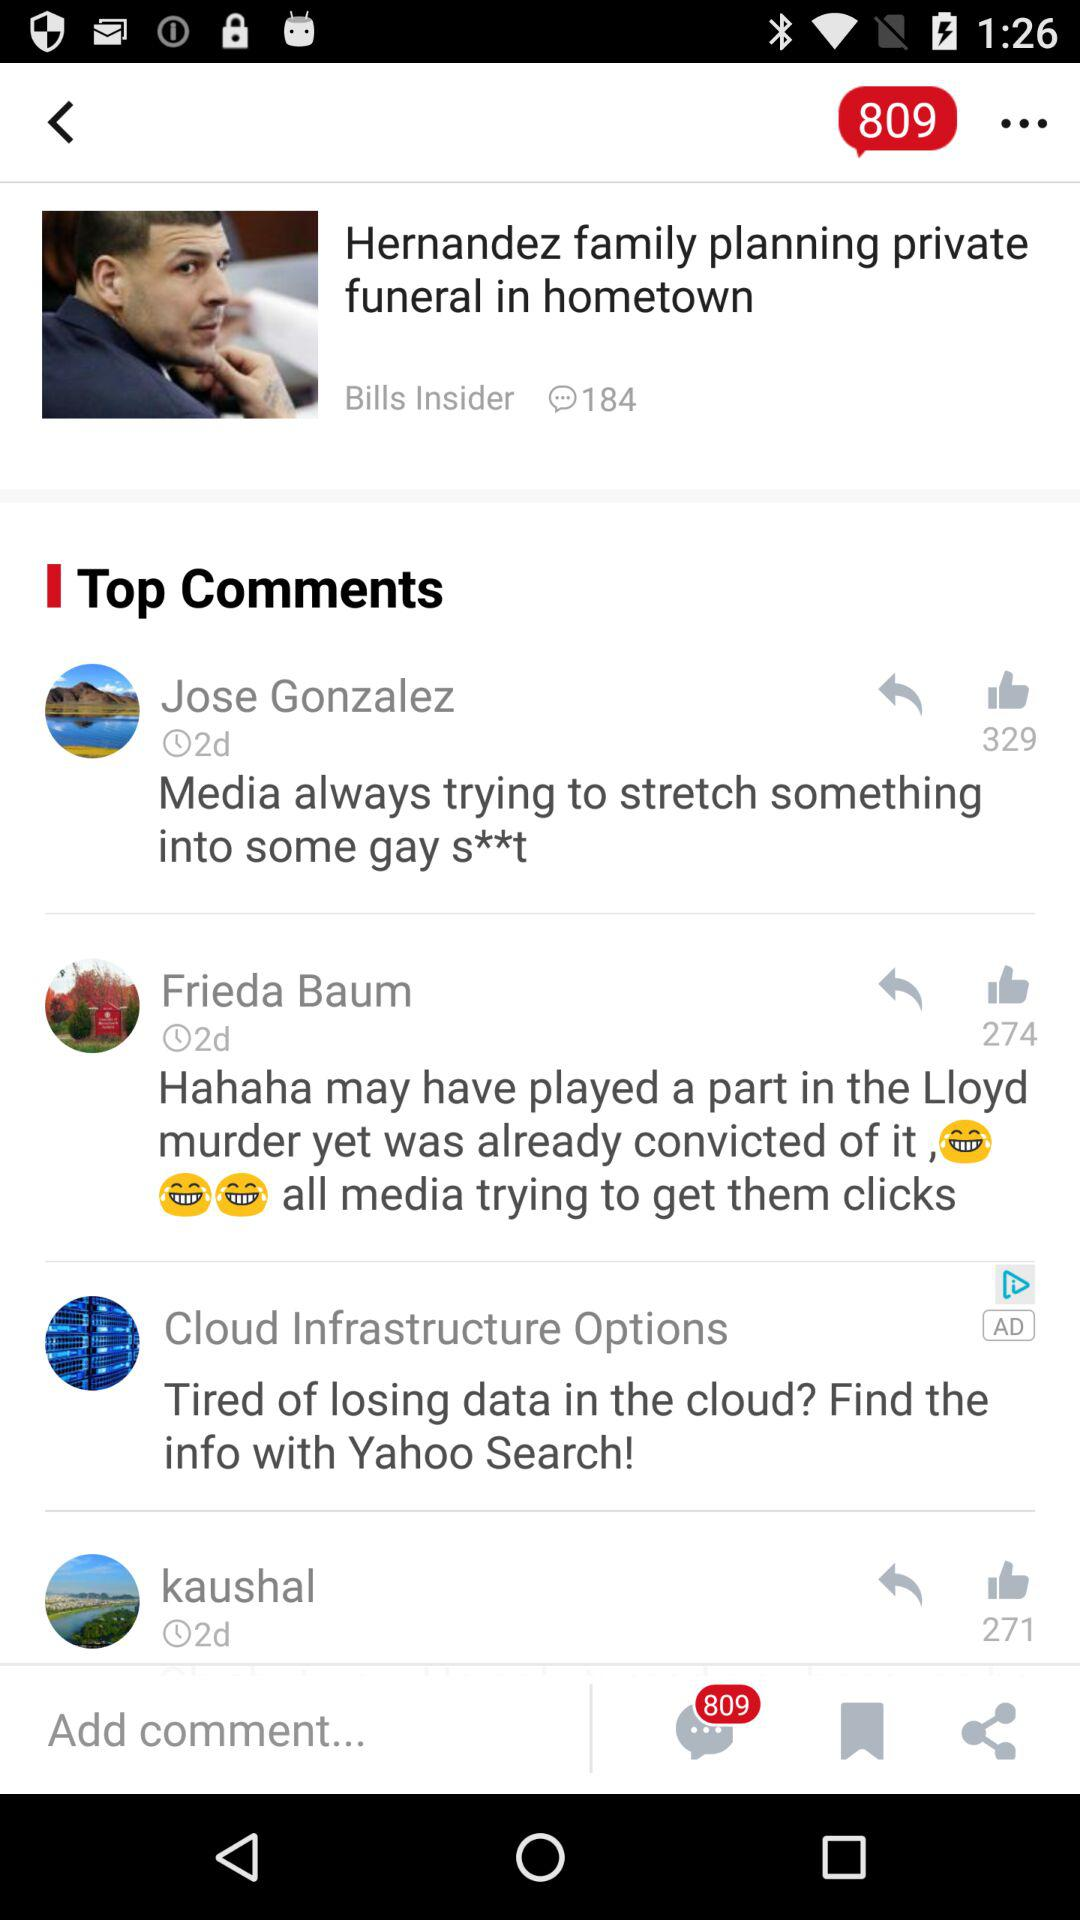How many comments are there for the "Hernandez family" post? There are 184 comments for the "Hernandez family" post. 